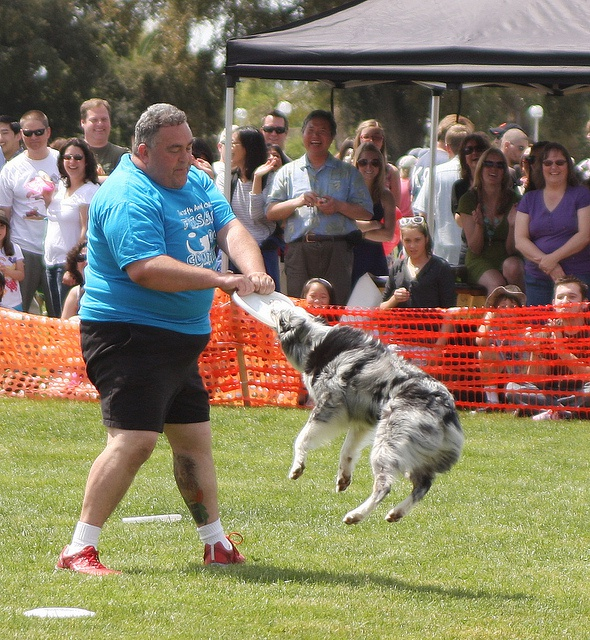Describe the objects in this image and their specific colors. I can see people in black, teal, and gray tones, people in black, brown, red, and maroon tones, dog in black, gray, darkgray, and lightgray tones, people in black, gray, maroon, and lightgray tones, and people in black, gray, purple, and navy tones in this image. 